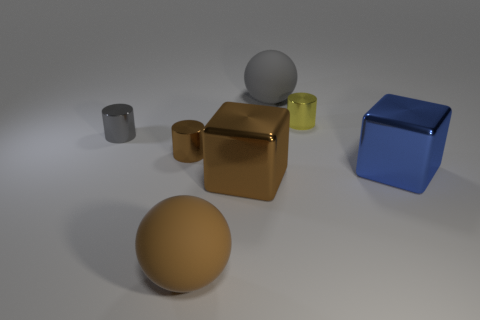The large brown object that is the same material as the tiny yellow cylinder is what shape?
Offer a terse response. Cube. There is a matte object that is behind the tiny gray thing; does it have the same shape as the gray metallic thing?
Keep it short and to the point. No. There is a metal cube in front of the object to the right of the yellow object; what is its size?
Offer a terse response. Large. There is a big thing that is made of the same material as the brown block; what color is it?
Your answer should be very brief. Blue. What number of gray things have the same size as the gray cylinder?
Provide a short and direct response. 0. How many cyan things are either cylinders or big metallic cubes?
Your response must be concise. 0. What number of objects are either large brown cubes or objects that are in front of the gray shiny object?
Provide a short and direct response. 4. What is the gray thing in front of the big gray ball made of?
Provide a short and direct response. Metal. There is a blue metallic thing that is the same size as the gray matte ball; what shape is it?
Give a very brief answer. Cube. Are there any tiny gray objects of the same shape as the tiny yellow shiny thing?
Your response must be concise. Yes. 